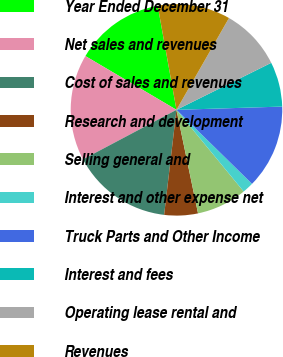<chart> <loc_0><loc_0><loc_500><loc_500><pie_chart><fcel>Year Ended December 31<fcel>Net sales and revenues<fcel>Cost of sales and revenues<fcel>Research and development<fcel>Selling general and<fcel>Interest and other expense net<fcel>Truck Parts and Other Income<fcel>Interest and fees<fcel>Operating lease rental and<fcel>Revenues<nl><fcel>13.67%<fcel>16.24%<fcel>15.38%<fcel>5.13%<fcel>7.69%<fcel>1.71%<fcel>12.82%<fcel>6.84%<fcel>9.4%<fcel>11.11%<nl></chart> 